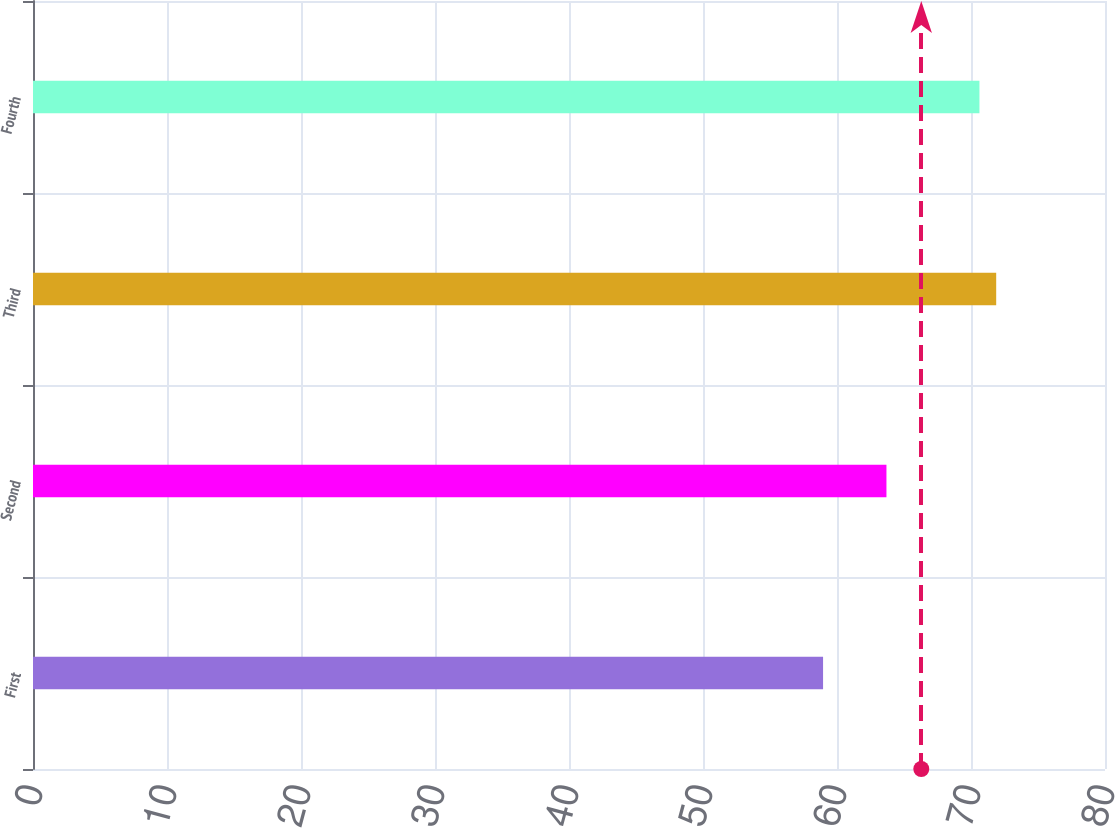Convert chart to OTSL. <chart><loc_0><loc_0><loc_500><loc_500><bar_chart><fcel>First<fcel>Second<fcel>Third<fcel>Fourth<nl><fcel>58.96<fcel>63.69<fcel>71.88<fcel>70.63<nl></chart> 